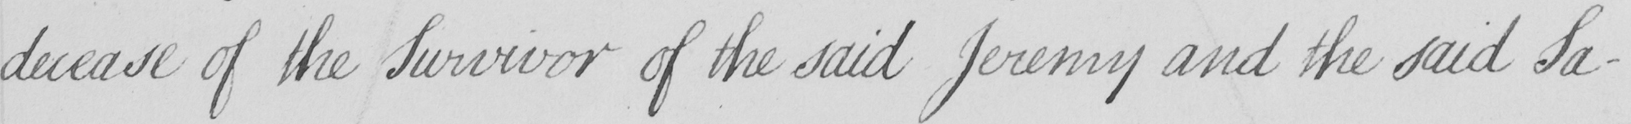What text is written in this handwritten line? decease of the Survivor of the said Jeremy and the said Sa- 